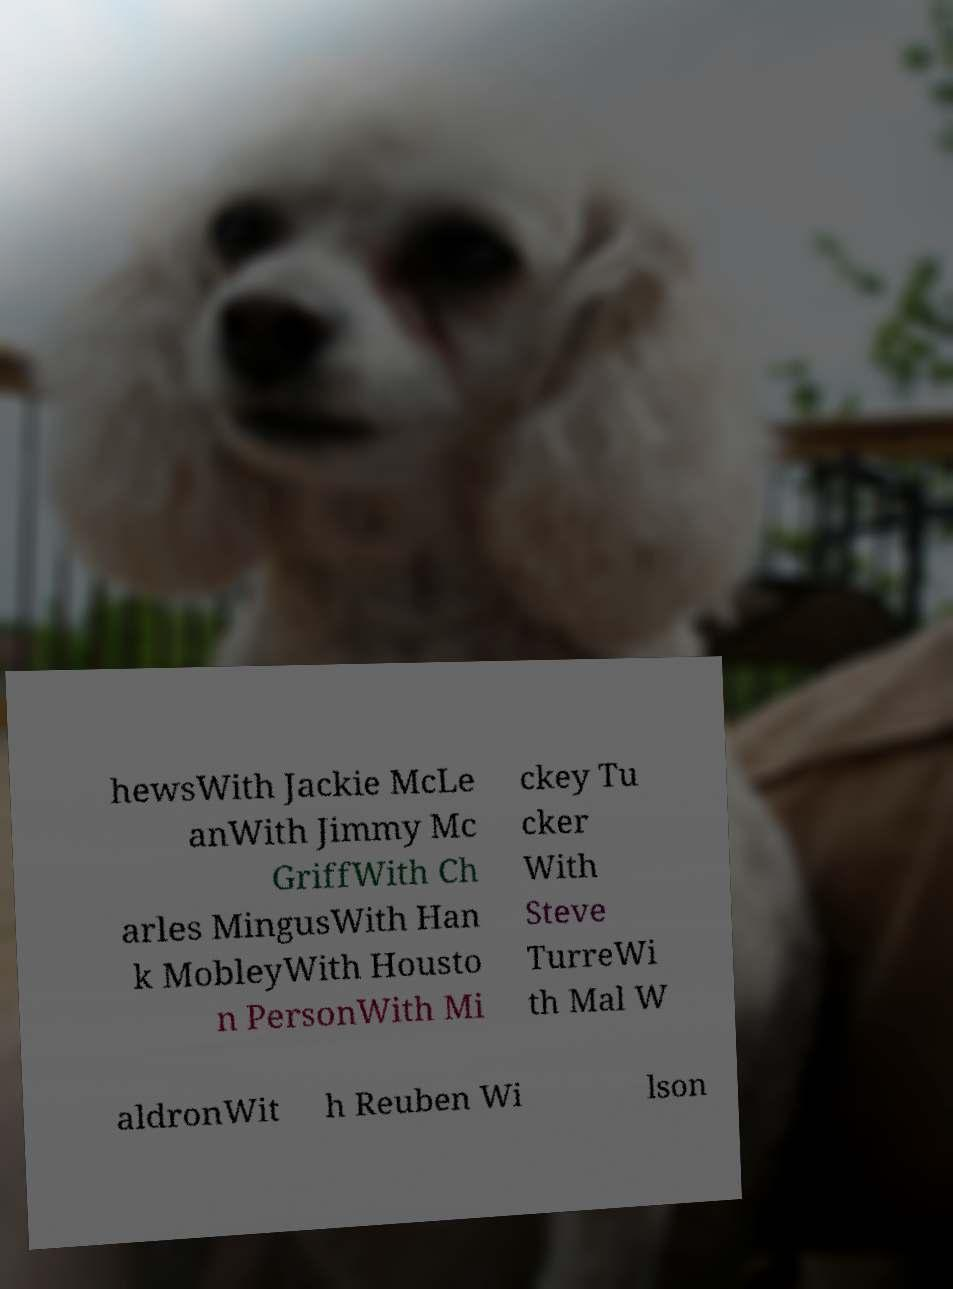There's text embedded in this image that I need extracted. Can you transcribe it verbatim? hewsWith Jackie McLe anWith Jimmy Mc GriffWith Ch arles MingusWith Han k MobleyWith Housto n PersonWith Mi ckey Tu cker With Steve TurreWi th Mal W aldronWit h Reuben Wi lson 